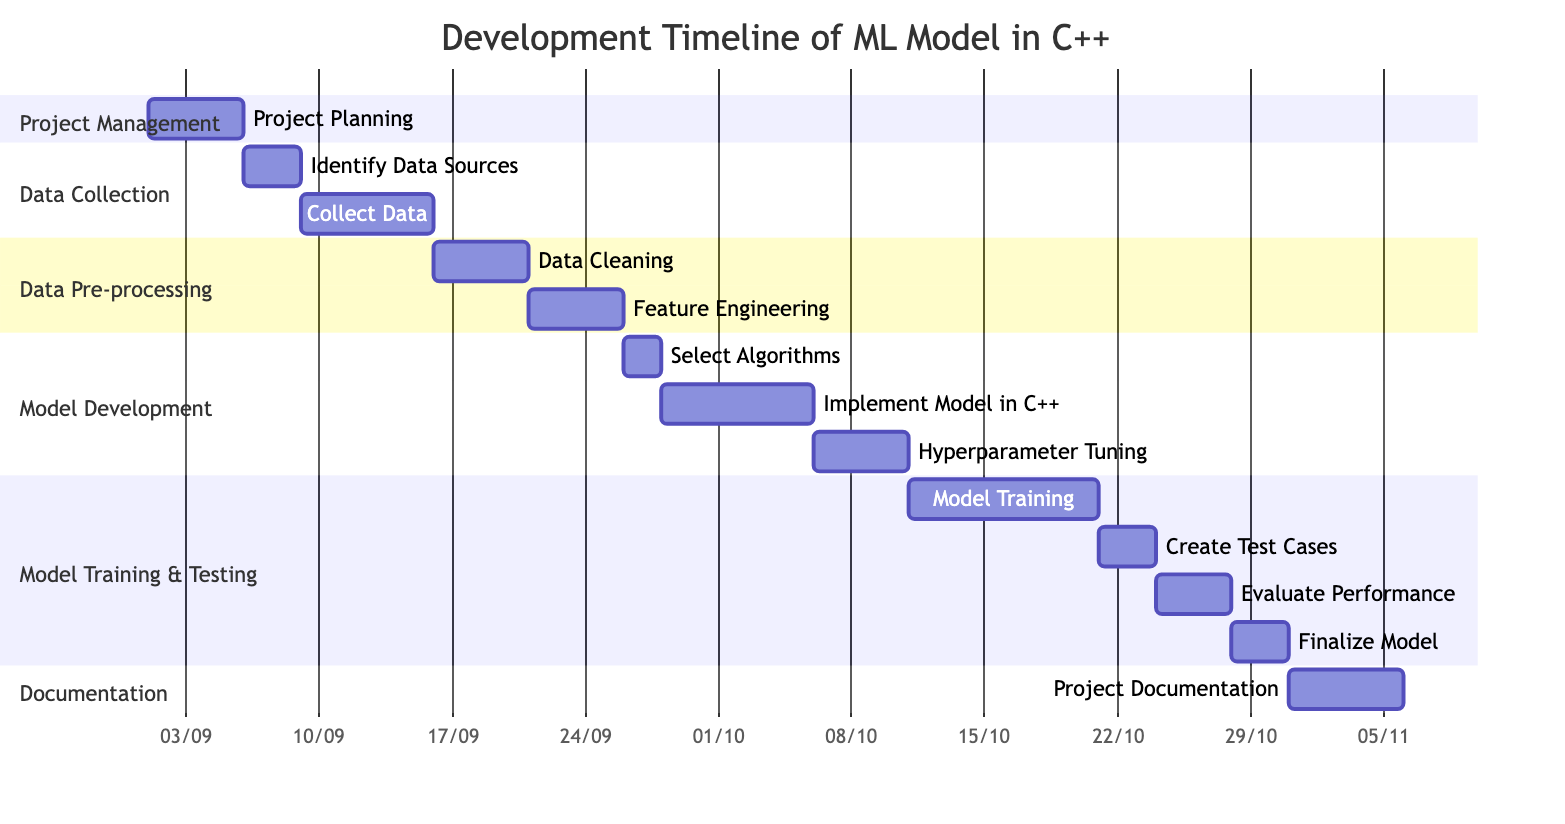What is the total duration of the project? The Gantt chart indicates that the project starts on September 1, 2023, and ends on November 5, 2023. This can be calculated by considering the days between these two dates, which total 66 days.
Answer: 66 days Which phase has the longest duration? By analyzing the tasks in the Gantt chart, the "Model Development" phase spans from September 26 to October 15, lasting for 20 days, which is longer than any other phase.
Answer: Model Development What are the start and end dates of the Data Pre-processing phase? The "Data Pre-processing" phase starts on September 16, 2023, and ends on September 25, 2023. This information is directly taken from the Gantt chart.
Answer: September 16, 2023 to September 25, 2023 How many days are allocated for Model Training? The "Model Training" task starts on October 11, 2023, and ends on October 20, 2023, which means it lasts for 10 days.
Answer: 10 days What date does the Create Test Cases subtask begin? The "Create Test Cases" subtask is located under the "Model Testing" phase and begins on October 21, 2023, as indicated in the diagram.
Answer: October 21, 2023 Which task follows Feature Engineering in the timeline? After the "Feature Engineering" task, which ends on September 25, 2023, the next task is "Model Development," which starts on September 26, 2023.
Answer: Model Development How many subtasks are there in the Model Development phase? The "Model Development" phase contains three subtasks, namely "Select Algorithms," "Implement Model in C++," and "Hyperparameter Tuning," as shown in the Gantt chart.
Answer: 3 subtasks What is the duration of the Data Collection phase? The "Data Collection" phase begins on September 6, 2023, and ends on September 15, 2023, giving it a total duration of 10 days.
Answer: 10 days When does Project Documentation start? According to the Gantt chart, "Project Documentation" starts on October 31, 2023, as indicated under the Documentation section.
Answer: October 31, 2023 